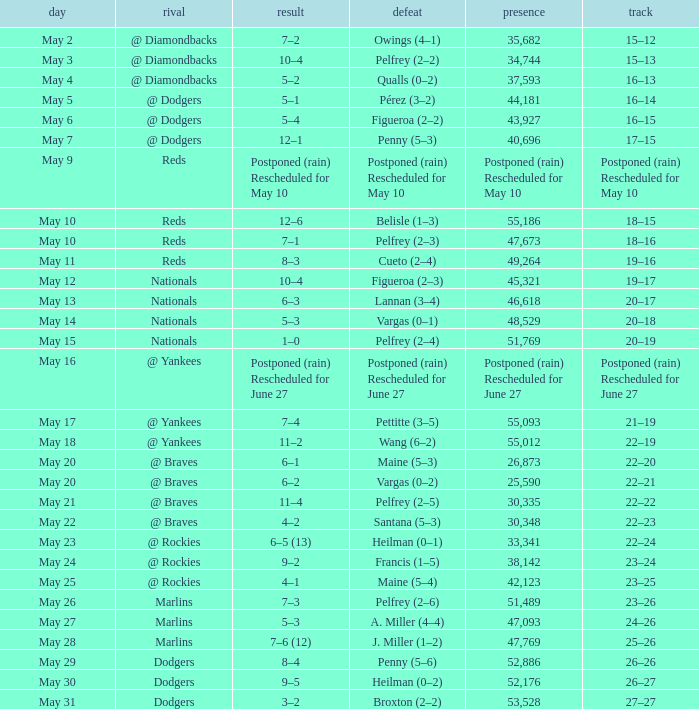Parse the full table. {'header': ['day', 'rival', 'result', 'defeat', 'presence', 'track'], 'rows': [['May 2', '@ Diamondbacks', '7–2', 'Owings (4–1)', '35,682', '15–12'], ['May 3', '@ Diamondbacks', '10–4', 'Pelfrey (2–2)', '34,744', '15–13'], ['May 4', '@ Diamondbacks', '5–2', 'Qualls (0–2)', '37,593', '16–13'], ['May 5', '@ Dodgers', '5–1', 'Pérez (3–2)', '44,181', '16–14'], ['May 6', '@ Dodgers', '5–4', 'Figueroa (2–2)', '43,927', '16–15'], ['May 7', '@ Dodgers', '12–1', 'Penny (5–3)', '40,696', '17–15'], ['May 9', 'Reds', 'Postponed (rain) Rescheduled for May 10', 'Postponed (rain) Rescheduled for May 10', 'Postponed (rain) Rescheduled for May 10', 'Postponed (rain) Rescheduled for May 10'], ['May 10', 'Reds', '12–6', 'Belisle (1–3)', '55,186', '18–15'], ['May 10', 'Reds', '7–1', 'Pelfrey (2–3)', '47,673', '18–16'], ['May 11', 'Reds', '8–3', 'Cueto (2–4)', '49,264', '19–16'], ['May 12', 'Nationals', '10–4', 'Figueroa (2–3)', '45,321', '19–17'], ['May 13', 'Nationals', '6–3', 'Lannan (3–4)', '46,618', '20–17'], ['May 14', 'Nationals', '5–3', 'Vargas (0–1)', '48,529', '20–18'], ['May 15', 'Nationals', '1–0', 'Pelfrey (2–4)', '51,769', '20–19'], ['May 16', '@ Yankees', 'Postponed (rain) Rescheduled for June 27', 'Postponed (rain) Rescheduled for June 27', 'Postponed (rain) Rescheduled for June 27', 'Postponed (rain) Rescheduled for June 27'], ['May 17', '@ Yankees', '7–4', 'Pettitte (3–5)', '55,093', '21–19'], ['May 18', '@ Yankees', '11–2', 'Wang (6–2)', '55,012', '22–19'], ['May 20', '@ Braves', '6–1', 'Maine (5–3)', '26,873', '22–20'], ['May 20', '@ Braves', '6–2', 'Vargas (0–2)', '25,590', '22–21'], ['May 21', '@ Braves', '11–4', 'Pelfrey (2–5)', '30,335', '22–22'], ['May 22', '@ Braves', '4–2', 'Santana (5–3)', '30,348', '22–23'], ['May 23', '@ Rockies', '6–5 (13)', 'Heilman (0–1)', '33,341', '22–24'], ['May 24', '@ Rockies', '9–2', 'Francis (1–5)', '38,142', '23–24'], ['May 25', '@ Rockies', '4–1', 'Maine (5–4)', '42,123', '23–25'], ['May 26', 'Marlins', '7–3', 'Pelfrey (2–6)', '51,489', '23–26'], ['May 27', 'Marlins', '5–3', 'A. Miller (4–4)', '47,093', '24–26'], ['May 28', 'Marlins', '7–6 (12)', 'J. Miller (1–2)', '47,769', '25–26'], ['May 29', 'Dodgers', '8–4', 'Penny (5–6)', '52,886', '26–26'], ['May 30', 'Dodgers', '9–5', 'Heilman (0–2)', '52,176', '26–27'], ['May 31', 'Dodgers', '3–2', 'Broxton (2–2)', '53,528', '27–27']]} Record of 19–16 occurred on what date? May 11. 